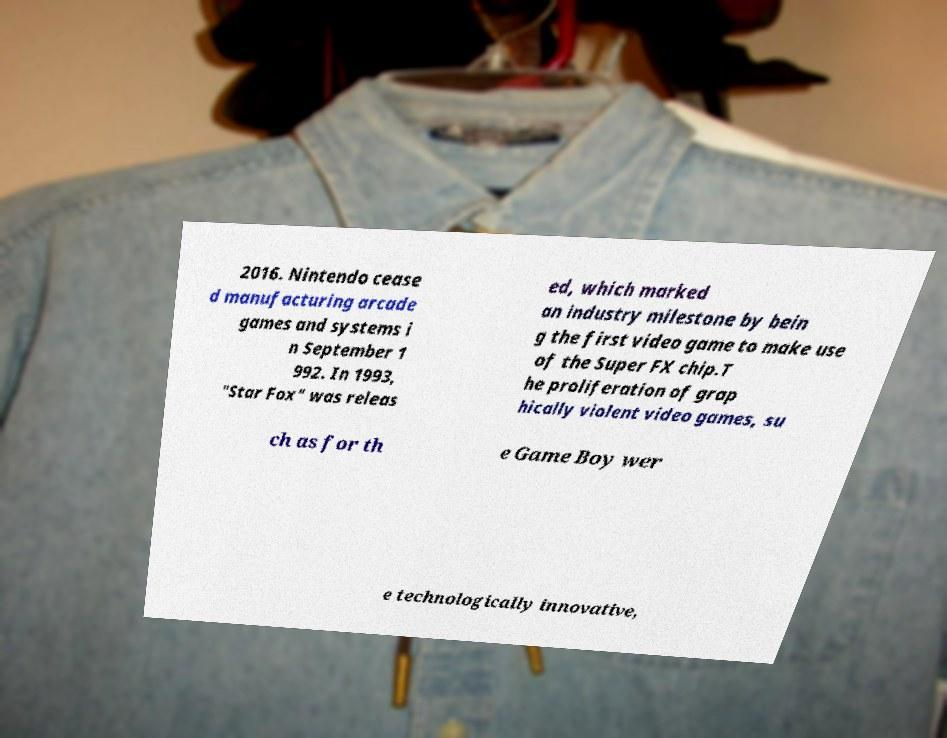Please read and relay the text visible in this image. What does it say? 2016. Nintendo cease d manufacturing arcade games and systems i n September 1 992. In 1993, "Star Fox" was releas ed, which marked an industry milestone by bein g the first video game to make use of the Super FX chip.T he proliferation of grap hically violent video games, su ch as for th e Game Boy wer e technologically innovative, 